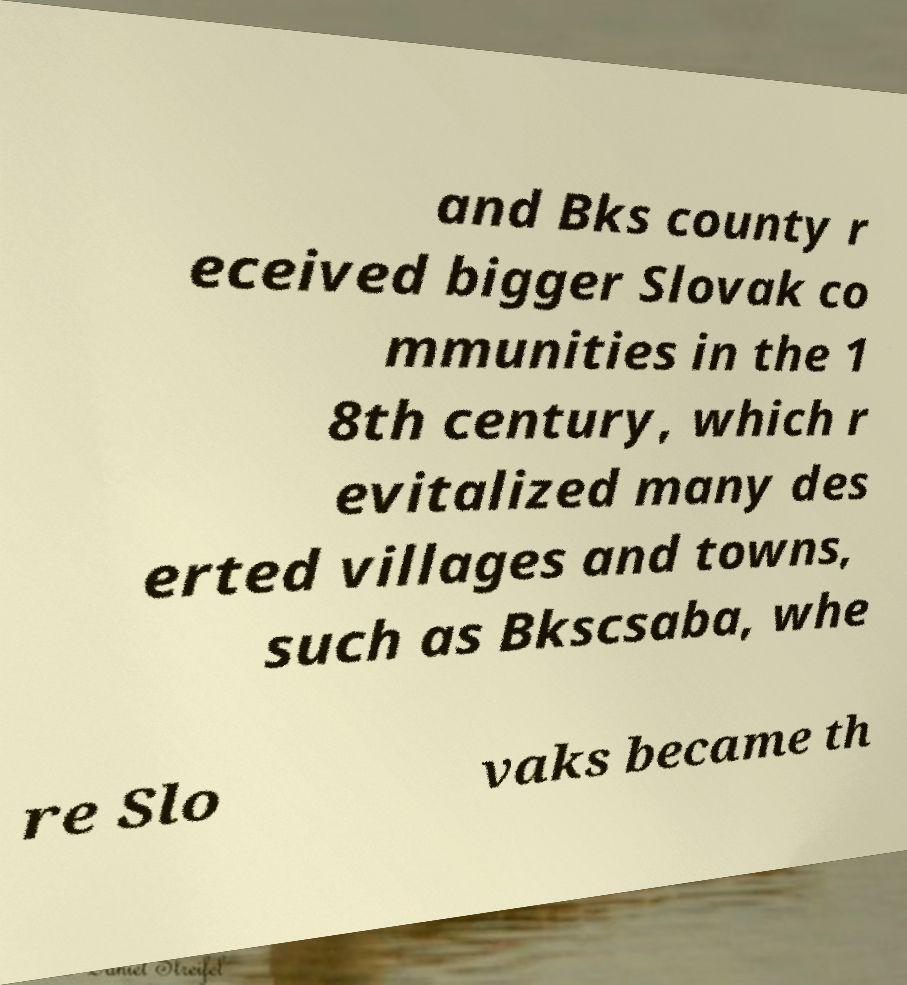I need the written content from this picture converted into text. Can you do that? and Bks county r eceived bigger Slovak co mmunities in the 1 8th century, which r evitalized many des erted villages and towns, such as Bkscsaba, whe re Slo vaks became th 